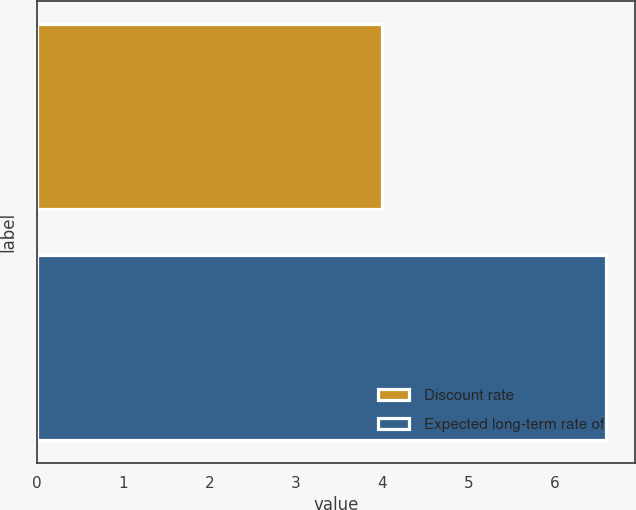Convert chart. <chart><loc_0><loc_0><loc_500><loc_500><bar_chart><fcel>Discount rate<fcel>Expected long-term rate of<nl><fcel>4<fcel>6.6<nl></chart> 